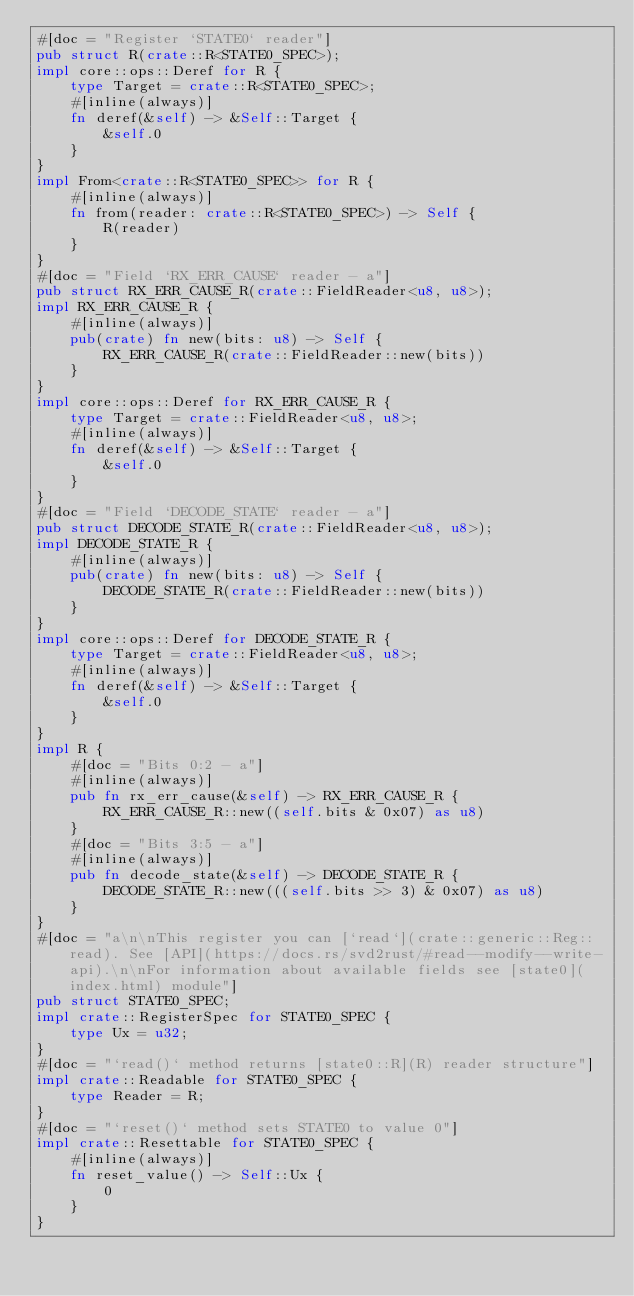Convert code to text. <code><loc_0><loc_0><loc_500><loc_500><_Rust_>#[doc = "Register `STATE0` reader"]
pub struct R(crate::R<STATE0_SPEC>);
impl core::ops::Deref for R {
    type Target = crate::R<STATE0_SPEC>;
    #[inline(always)]
    fn deref(&self) -> &Self::Target {
        &self.0
    }
}
impl From<crate::R<STATE0_SPEC>> for R {
    #[inline(always)]
    fn from(reader: crate::R<STATE0_SPEC>) -> Self {
        R(reader)
    }
}
#[doc = "Field `RX_ERR_CAUSE` reader - a"]
pub struct RX_ERR_CAUSE_R(crate::FieldReader<u8, u8>);
impl RX_ERR_CAUSE_R {
    #[inline(always)]
    pub(crate) fn new(bits: u8) -> Self {
        RX_ERR_CAUSE_R(crate::FieldReader::new(bits))
    }
}
impl core::ops::Deref for RX_ERR_CAUSE_R {
    type Target = crate::FieldReader<u8, u8>;
    #[inline(always)]
    fn deref(&self) -> &Self::Target {
        &self.0
    }
}
#[doc = "Field `DECODE_STATE` reader - a"]
pub struct DECODE_STATE_R(crate::FieldReader<u8, u8>);
impl DECODE_STATE_R {
    #[inline(always)]
    pub(crate) fn new(bits: u8) -> Self {
        DECODE_STATE_R(crate::FieldReader::new(bits))
    }
}
impl core::ops::Deref for DECODE_STATE_R {
    type Target = crate::FieldReader<u8, u8>;
    #[inline(always)]
    fn deref(&self) -> &Self::Target {
        &self.0
    }
}
impl R {
    #[doc = "Bits 0:2 - a"]
    #[inline(always)]
    pub fn rx_err_cause(&self) -> RX_ERR_CAUSE_R {
        RX_ERR_CAUSE_R::new((self.bits & 0x07) as u8)
    }
    #[doc = "Bits 3:5 - a"]
    #[inline(always)]
    pub fn decode_state(&self) -> DECODE_STATE_R {
        DECODE_STATE_R::new(((self.bits >> 3) & 0x07) as u8)
    }
}
#[doc = "a\n\nThis register you can [`read`](crate::generic::Reg::read). See [API](https://docs.rs/svd2rust/#read--modify--write-api).\n\nFor information about available fields see [state0](index.html) module"]
pub struct STATE0_SPEC;
impl crate::RegisterSpec for STATE0_SPEC {
    type Ux = u32;
}
#[doc = "`read()` method returns [state0::R](R) reader structure"]
impl crate::Readable for STATE0_SPEC {
    type Reader = R;
}
#[doc = "`reset()` method sets STATE0 to value 0"]
impl crate::Resettable for STATE0_SPEC {
    #[inline(always)]
    fn reset_value() -> Self::Ux {
        0
    }
}
</code> 